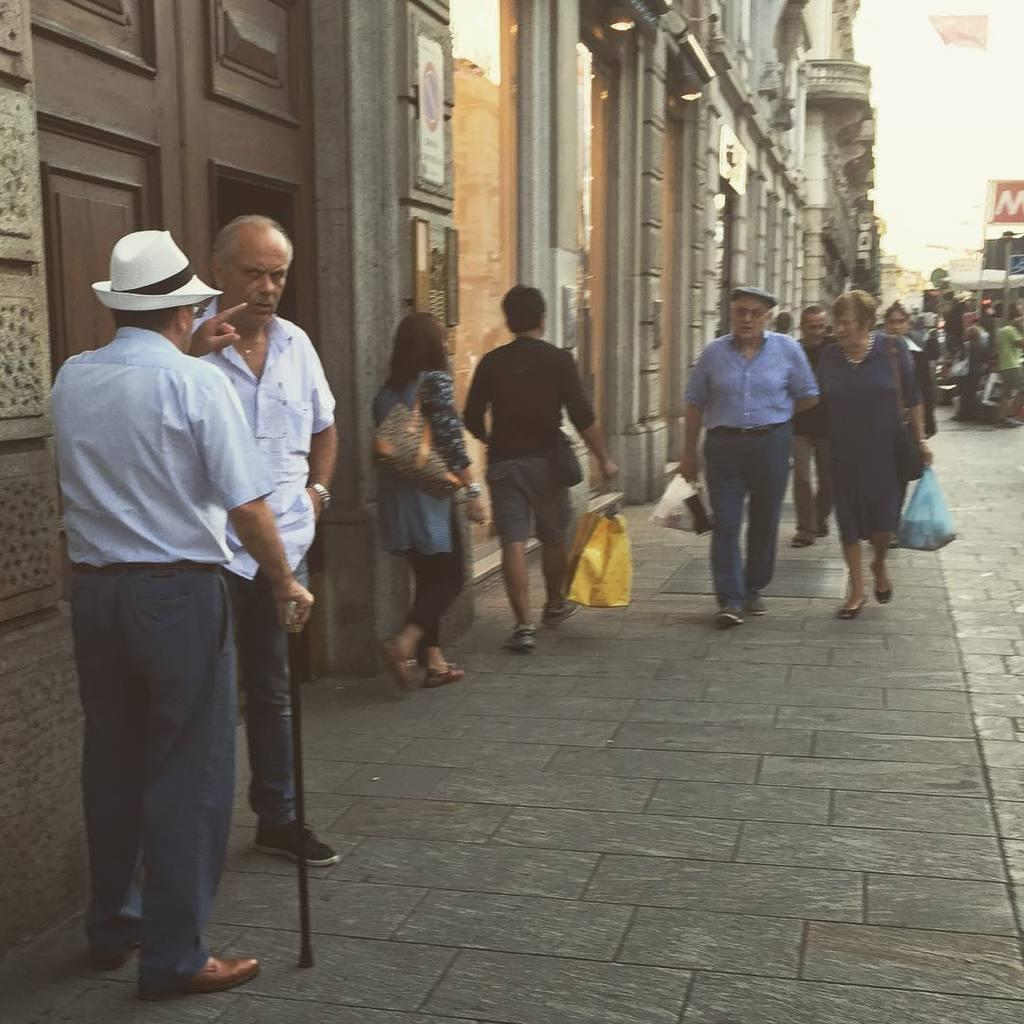Who or what can be seen in the image? There are people in the image. What are some of the people doing in the image? Some people are holding objects. What type of structures are visible in the image? There are buildings with doors in the image. Is there any text or writing present in the image? Yes, there is a poster with text in the image. How many basketballs can be seen in the image? There are no basketballs present in the image. What type of cap is the person wearing in the image? There is no person wearing a cap in the image. 